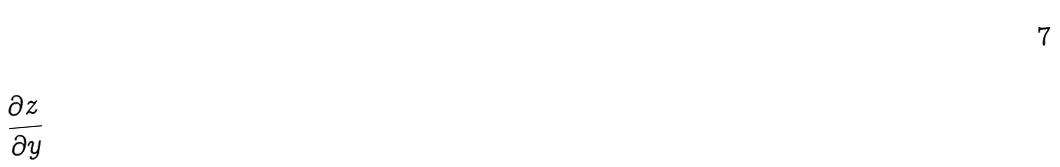<formula> <loc_0><loc_0><loc_500><loc_500>\frac { \partial z } { \partial y }</formula> 